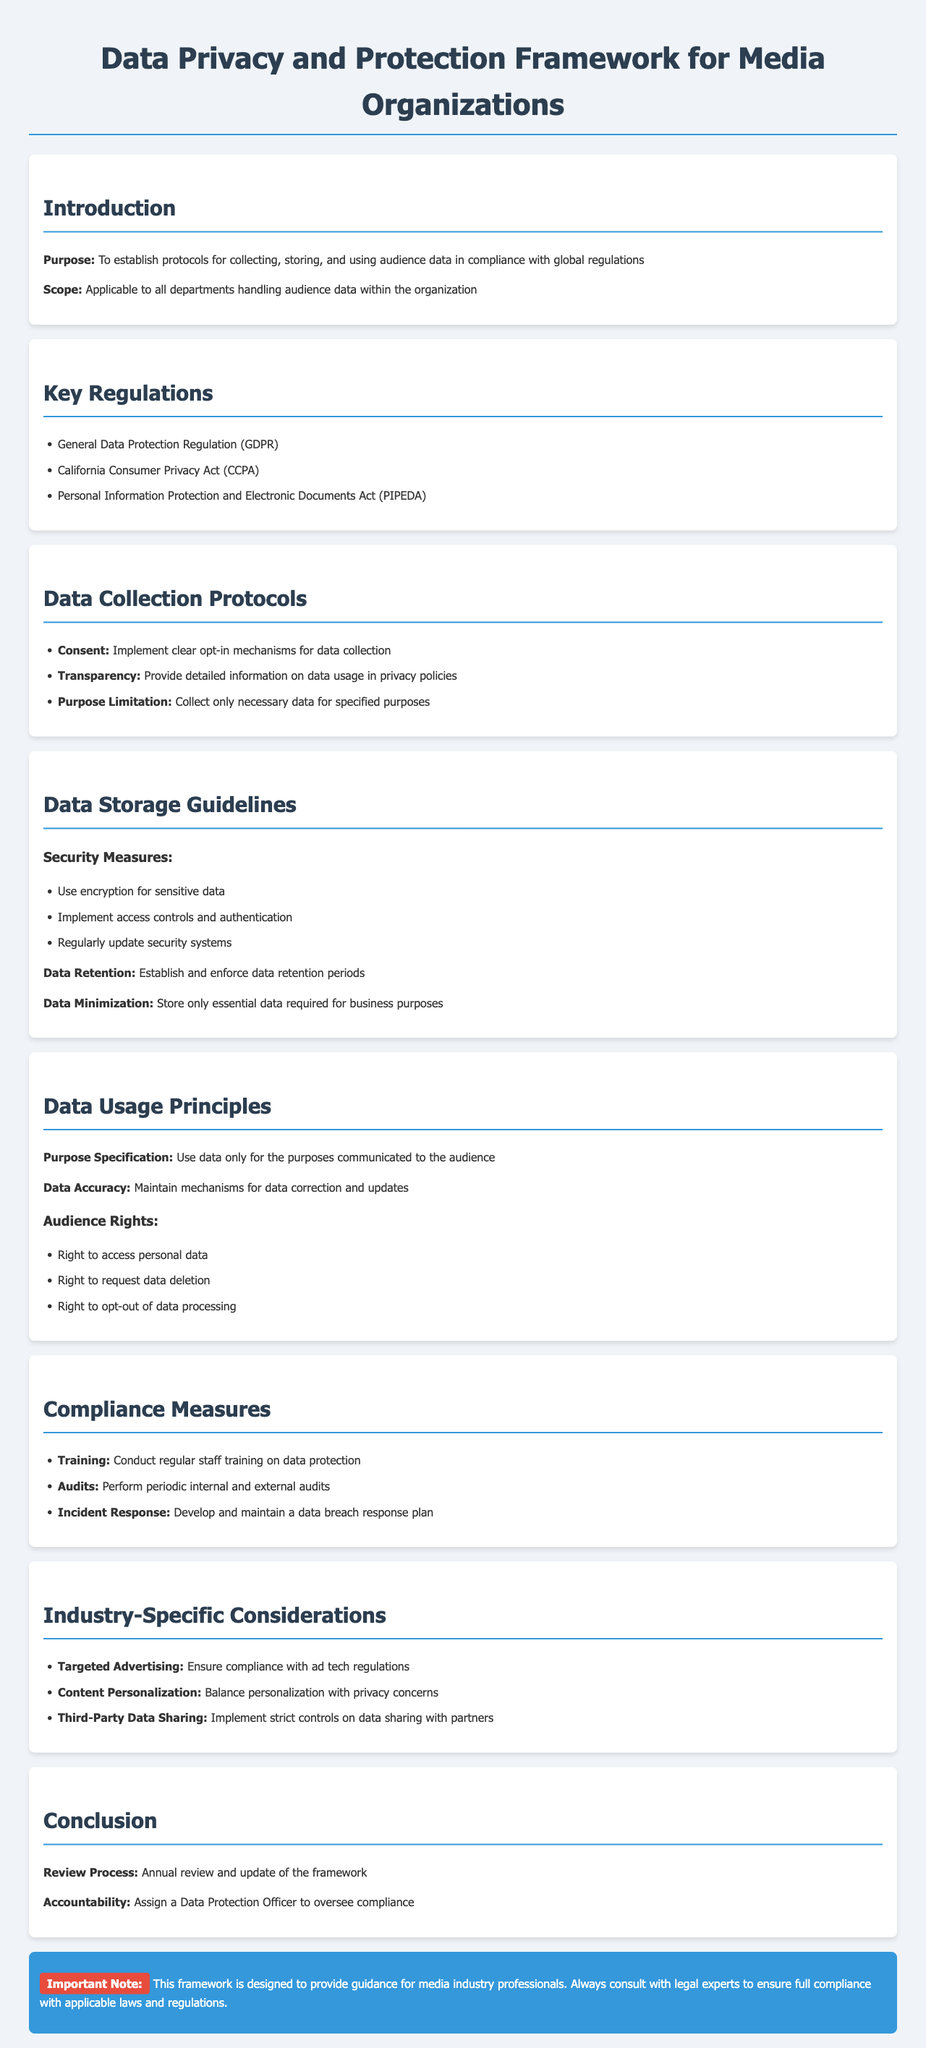What is the purpose of the framework? The purpose is to establish protocols for collecting, storing, and using audience data in compliance with global regulations.
Answer: To establish protocols for collecting, storing, and using audience data in compliance with global regulations Which regulation is mentioned as GDPR? GDPR stands for the General Data Protection Regulation, listed under Key Regulations.
Answer: General Data Protection Regulation What is one of the data collection protocols? One of the protocols is to implement clear opt-in mechanisms for data collection, as detailed in the Data Collection Protocols section.
Answer: Implement clear opt-in mechanisms for data collection What security measure is suggested for sensitive data? The document suggests using encryption for sensitive data under Security Measures in the Data Storage Guidelines.
Answer: Use encryption for sensitive data What rights do audiences have regarding their personal data? The audiences have the right to access personal data, request data deletion, and opt-out of data processing, as stated in the Audience Rights section.
Answer: Right to access personal data, right to request data deletion, right to opt-out of data processing How often should the framework be reviewed? According to the Conclusion, the framework should be reviewed annually.
Answer: Annual review Who is responsible for overseeing compliance? The responsibility for overseeing compliance is assigned to a Data Protection Officer, as mentioned in the Conclusion.
Answer: Data Protection Officer What is a specific consideration mentioned for targeted advertising? The document highlights the need to ensure compliance with ad tech regulations.
Answer: Ensure compliance with ad tech regulations What type of training is recommended for staff? Regular staff training on data protection is recommended in the Compliance Measures section.
Answer: Conduct regular staff training on data protection 